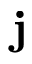<formula> <loc_0><loc_0><loc_500><loc_500>j</formula> 